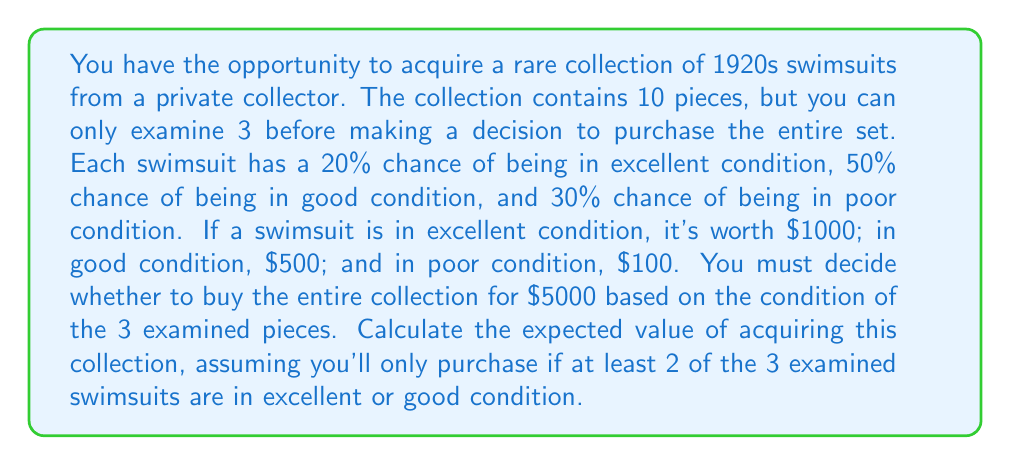Provide a solution to this math problem. Let's break this problem down step-by-step:

1) First, we need to calculate the probability of a swimsuit being in excellent or good condition:
   $P(\text{excellent or good}) = 0.20 + 0.50 = 0.70$

2) The probability of at least 2 out of 3 examined swimsuits being in excellent or good condition can be calculated using the binomial probability formula:
   $$P(\text{at least 2 out of 3}) = \binom{3}{2}0.70^2(0.30) + \binom{3}{3}0.70^3 = 0.784$$

3) Now, let's calculate the expected value of a single swimsuit:
   $E(\text{value}) = 1000(0.20) + 500(0.50) + 100(0.30) = 200 + 250 + 30 = $480$

4) The expected value of the entire collection of 10 swimsuits is:
   $E(\text{collection}) = 10 \times $480 = $4800$

5) The expected value of acquiring the collection, given our decision rule, is:
   $E(\text{acquisition}) = 0.784($4800 - $5000) + 0.216(0) = -$156.80$

   Here, 0.784 is the probability of buying (when at least 2 out of 3 are excellent or good), 
   $4800 - $5000 is the expected profit when buying, and 
   0.216 is the probability of not buying (with $0 profit in this case).
Answer: The expected value of acquiring the rare swimsuit collection is -$156.80. 